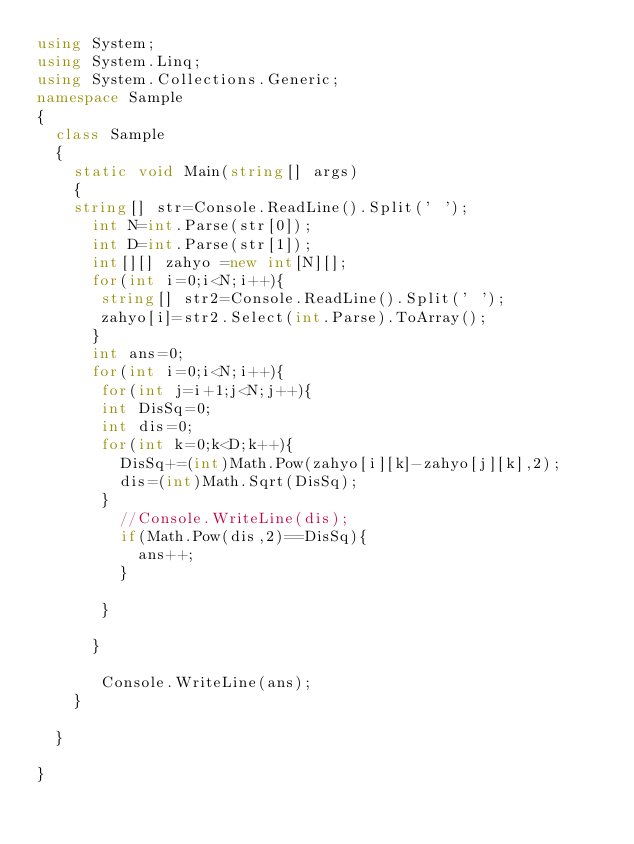<code> <loc_0><loc_0><loc_500><loc_500><_C#_>using System;
using System.Linq;
using System.Collections.Generic;
namespace Sample
{
  class Sample
  {
    static void Main(string[] args)
    {
    string[] str=Console.ReadLine().Split(' '); 
      int N=int.Parse(str[0]);
      int D=int.Parse(str[1]);
      int[][] zahyo =new int[N][];
      for(int i=0;i<N;i++){
       string[] str2=Console.ReadLine().Split(' ');
       zahyo[i]=str2.Select(int.Parse).ToArray();
      }
      int ans=0;
      for(int i=0;i<N;i++){
       for(int j=i+1;j<N;j++){     
       int DisSq=0;
       int dis=0;
       for(int k=0;k<D;k++){
         DisSq+=(int)Math.Pow(zahyo[i][k]-zahyo[j][k],2);
         dis=(int)Math.Sqrt(DisSq);
       }
         //Console.WriteLine(dis);
         if(Math.Pow(dis,2)==DisSq){
           ans++;
         }
         
       }
       
      }
      
       Console.WriteLine(ans);
    }
    
  }

}
</code> 